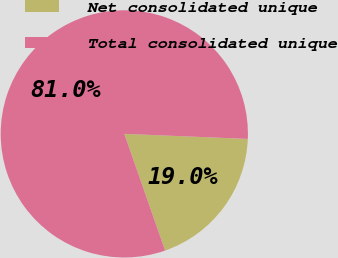Convert chart to OTSL. <chart><loc_0><loc_0><loc_500><loc_500><pie_chart><fcel>Net consolidated unique<fcel>Total consolidated unique<nl><fcel>19.0%<fcel>81.0%<nl></chart> 